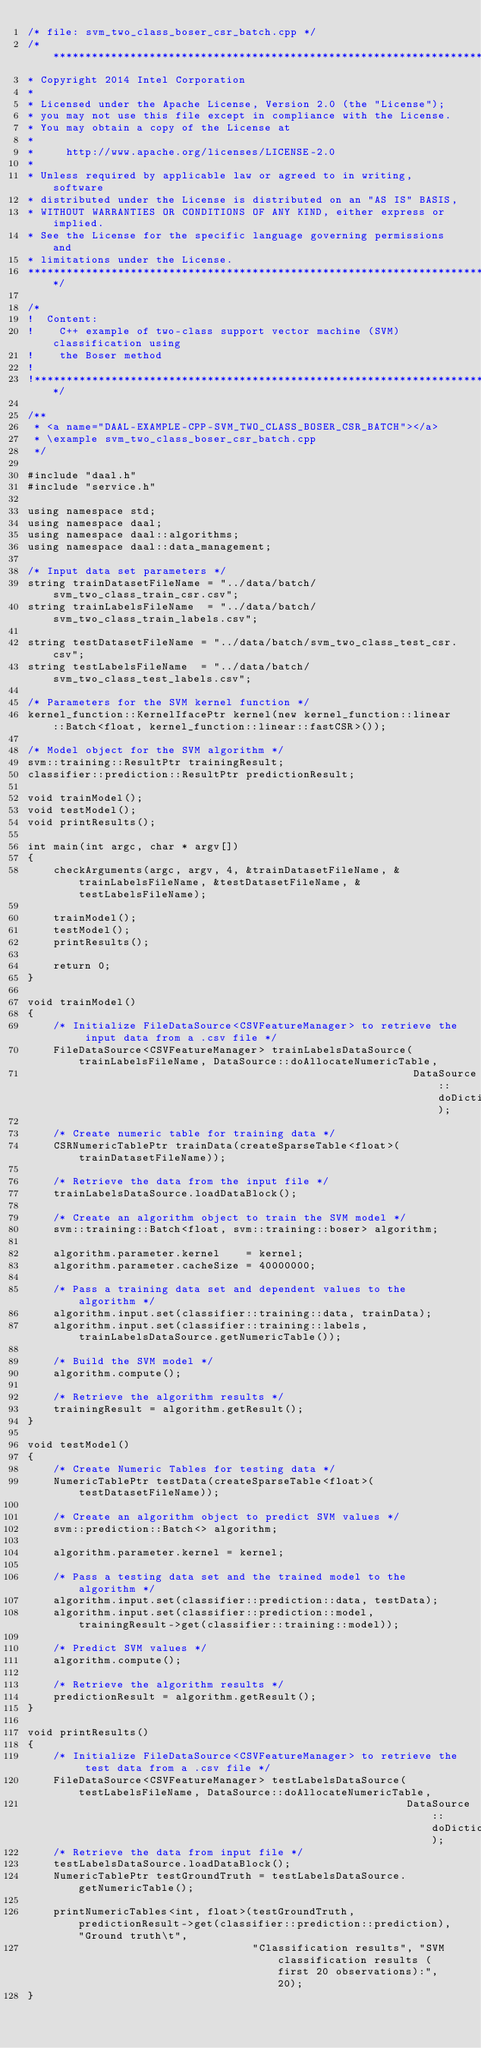<code> <loc_0><loc_0><loc_500><loc_500><_C++_>/* file: svm_two_class_boser_csr_batch.cpp */
/*******************************************************************************
* Copyright 2014 Intel Corporation
*
* Licensed under the Apache License, Version 2.0 (the "License");
* you may not use this file except in compliance with the License.
* You may obtain a copy of the License at
*
*     http://www.apache.org/licenses/LICENSE-2.0
*
* Unless required by applicable law or agreed to in writing, software
* distributed under the License is distributed on an "AS IS" BASIS,
* WITHOUT WARRANTIES OR CONDITIONS OF ANY KIND, either express or implied.
* See the License for the specific language governing permissions and
* limitations under the License.
*******************************************************************************/

/*
!  Content:
!    C++ example of two-class support vector machine (SVM) classification using
!    the Boser method
!
!******************************************************************************/

/**
 * <a name="DAAL-EXAMPLE-CPP-SVM_TWO_CLASS_BOSER_CSR_BATCH"></a>
 * \example svm_two_class_boser_csr_batch.cpp
 */

#include "daal.h"
#include "service.h"

using namespace std;
using namespace daal;
using namespace daal::algorithms;
using namespace daal::data_management;

/* Input data set parameters */
string trainDatasetFileName = "../data/batch/svm_two_class_train_csr.csv";
string trainLabelsFileName  = "../data/batch/svm_two_class_train_labels.csv";

string testDatasetFileName = "../data/batch/svm_two_class_test_csr.csv";
string testLabelsFileName  = "../data/batch/svm_two_class_test_labels.csv";

/* Parameters for the SVM kernel function */
kernel_function::KernelIfacePtr kernel(new kernel_function::linear::Batch<float, kernel_function::linear::fastCSR>());

/* Model object for the SVM algorithm */
svm::training::ResultPtr trainingResult;
classifier::prediction::ResultPtr predictionResult;

void trainModel();
void testModel();
void printResults();

int main(int argc, char * argv[])
{
    checkArguments(argc, argv, 4, &trainDatasetFileName, &trainLabelsFileName, &testDatasetFileName, &testLabelsFileName);

    trainModel();
    testModel();
    printResults();

    return 0;
}

void trainModel()
{
    /* Initialize FileDataSource<CSVFeatureManager> to retrieve the input data from a .csv file */
    FileDataSource<CSVFeatureManager> trainLabelsDataSource(trainLabelsFileName, DataSource::doAllocateNumericTable,
                                                            DataSource::doDictionaryFromContext);

    /* Create numeric table for training data */
    CSRNumericTablePtr trainData(createSparseTable<float>(trainDatasetFileName));

    /* Retrieve the data from the input file */
    trainLabelsDataSource.loadDataBlock();

    /* Create an algorithm object to train the SVM model */
    svm::training::Batch<float, svm::training::boser> algorithm;

    algorithm.parameter.kernel    = kernel;
    algorithm.parameter.cacheSize = 40000000;

    /* Pass a training data set and dependent values to the algorithm */
    algorithm.input.set(classifier::training::data, trainData);
    algorithm.input.set(classifier::training::labels, trainLabelsDataSource.getNumericTable());

    /* Build the SVM model */
    algorithm.compute();

    /* Retrieve the algorithm results */
    trainingResult = algorithm.getResult();
}

void testModel()
{
    /* Create Numeric Tables for testing data */
    NumericTablePtr testData(createSparseTable<float>(testDatasetFileName));

    /* Create an algorithm object to predict SVM values */
    svm::prediction::Batch<> algorithm;

    algorithm.parameter.kernel = kernel;

    /* Pass a testing data set and the trained model to the algorithm */
    algorithm.input.set(classifier::prediction::data, testData);
    algorithm.input.set(classifier::prediction::model, trainingResult->get(classifier::training::model));

    /* Predict SVM values */
    algorithm.compute();

    /* Retrieve the algorithm results */
    predictionResult = algorithm.getResult();
}

void printResults()
{
    /* Initialize FileDataSource<CSVFeatureManager> to retrieve the test data from a .csv file */
    FileDataSource<CSVFeatureManager> testLabelsDataSource(testLabelsFileName, DataSource::doAllocateNumericTable,
                                                           DataSource::doDictionaryFromContext);
    /* Retrieve the data from input file */
    testLabelsDataSource.loadDataBlock();
    NumericTablePtr testGroundTruth = testLabelsDataSource.getNumericTable();

    printNumericTables<int, float>(testGroundTruth, predictionResult->get(classifier::prediction::prediction), "Ground truth\t",
                                   "Classification results", "SVM classification results (first 20 observations):", 20);
}
</code> 